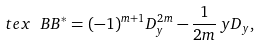Convert formula to latex. <formula><loc_0><loc_0><loc_500><loc_500>\ t e x { \ B B ^ { * } = ( - 1 ) ^ { m + 1 } D ^ { 2 m } _ { y } - \frac { 1 } { 2 m } \, y D _ { y } , }</formula> 